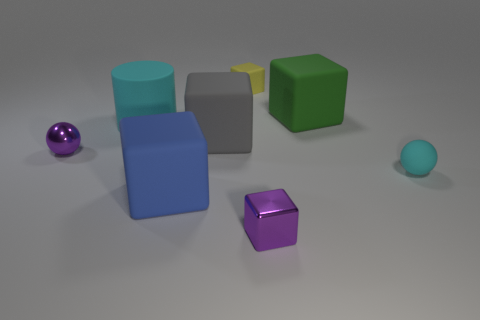Subtract all yellow cubes. How many cubes are left? 4 Subtract all large blue cubes. How many cubes are left? 4 Subtract 1 blocks. How many blocks are left? 4 Subtract all cyan cubes. Subtract all cyan cylinders. How many cubes are left? 5 Add 2 matte objects. How many objects exist? 10 Subtract all cubes. How many objects are left? 3 Add 7 purple shiny balls. How many purple shiny balls are left? 8 Add 4 tiny yellow matte blocks. How many tiny yellow matte blocks exist? 5 Subtract 0 brown cubes. How many objects are left? 8 Subtract all small red rubber cubes. Subtract all small yellow objects. How many objects are left? 7 